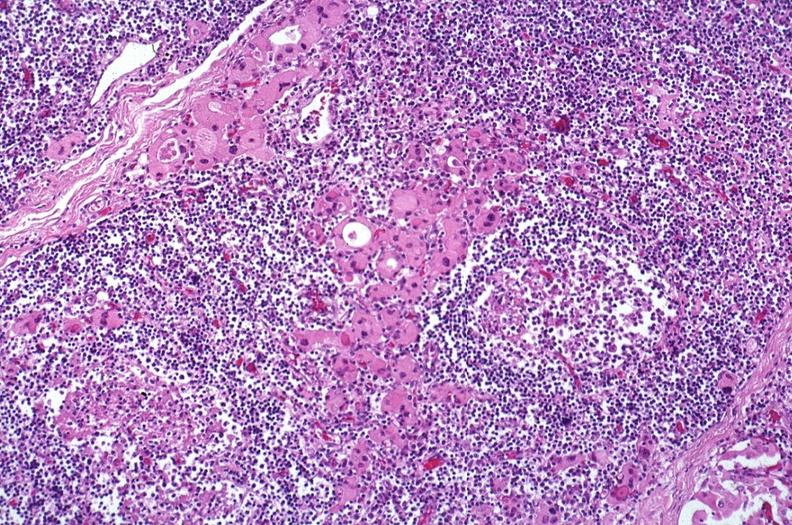what does this image show?
Answer the question using a single word or phrase. Hashimoto 's thyroiditis 